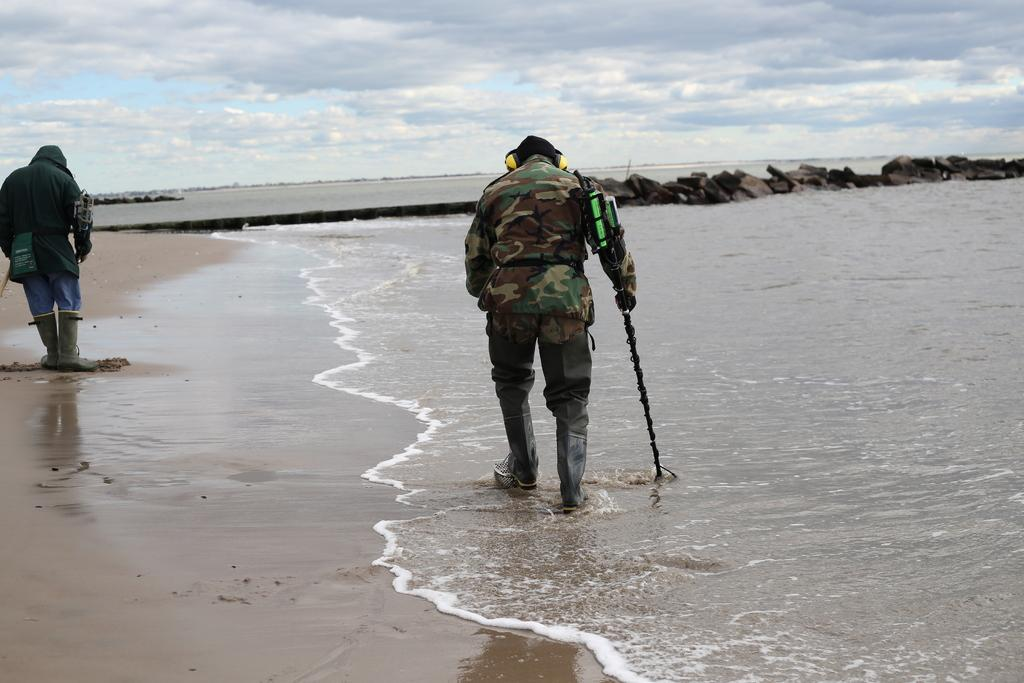How many people are in the image? There are people in the image, but the exact number is not specified. What is one person holding in the image? One person is holding a stick in the image. What type of natural elements can be seen in the image? There are rocks and water visible in the image. What is the condition of the sky in the image? The sky is cloudy in the image. What is the end result of the rainstorm in the image? There is no rainstorm present in the image, so there is no end result to discuss. Can you provide an example of a person in the image who is not holding a stick? The facts provided do not specify any other objects being held by the people in the image, so it is impossible to provide an example of a person not holding a stick. 